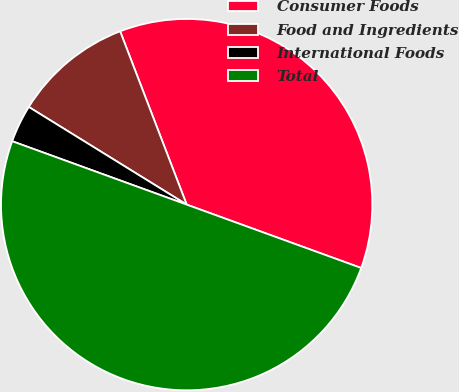Convert chart to OTSL. <chart><loc_0><loc_0><loc_500><loc_500><pie_chart><fcel>Consumer Foods<fcel>Food and Ingredients<fcel>International Foods<fcel>Total<nl><fcel>36.38%<fcel>10.35%<fcel>3.27%<fcel>50.0%<nl></chart> 